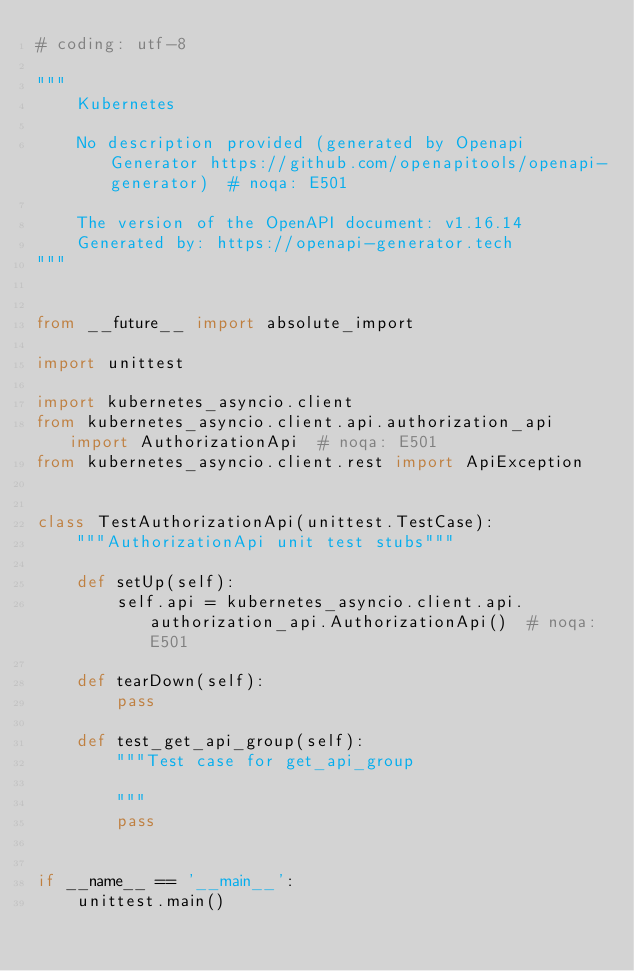Convert code to text. <code><loc_0><loc_0><loc_500><loc_500><_Python_># coding: utf-8

"""
    Kubernetes

    No description provided (generated by Openapi Generator https://github.com/openapitools/openapi-generator)  # noqa: E501

    The version of the OpenAPI document: v1.16.14
    Generated by: https://openapi-generator.tech
"""


from __future__ import absolute_import

import unittest

import kubernetes_asyncio.client
from kubernetes_asyncio.client.api.authorization_api import AuthorizationApi  # noqa: E501
from kubernetes_asyncio.client.rest import ApiException


class TestAuthorizationApi(unittest.TestCase):
    """AuthorizationApi unit test stubs"""

    def setUp(self):
        self.api = kubernetes_asyncio.client.api.authorization_api.AuthorizationApi()  # noqa: E501

    def tearDown(self):
        pass

    def test_get_api_group(self):
        """Test case for get_api_group

        """
        pass


if __name__ == '__main__':
    unittest.main()
</code> 